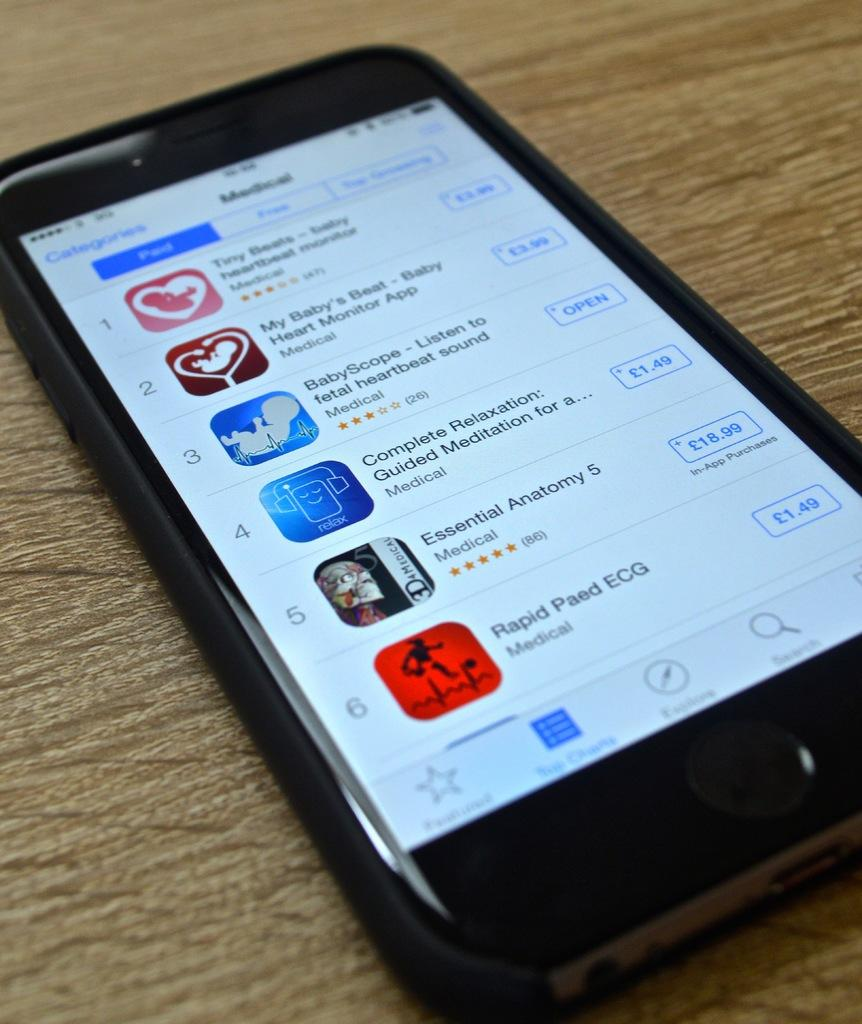Provide a one-sentence caption for the provided image. A cellphone showing the many apps on the screen and the purchase price. 